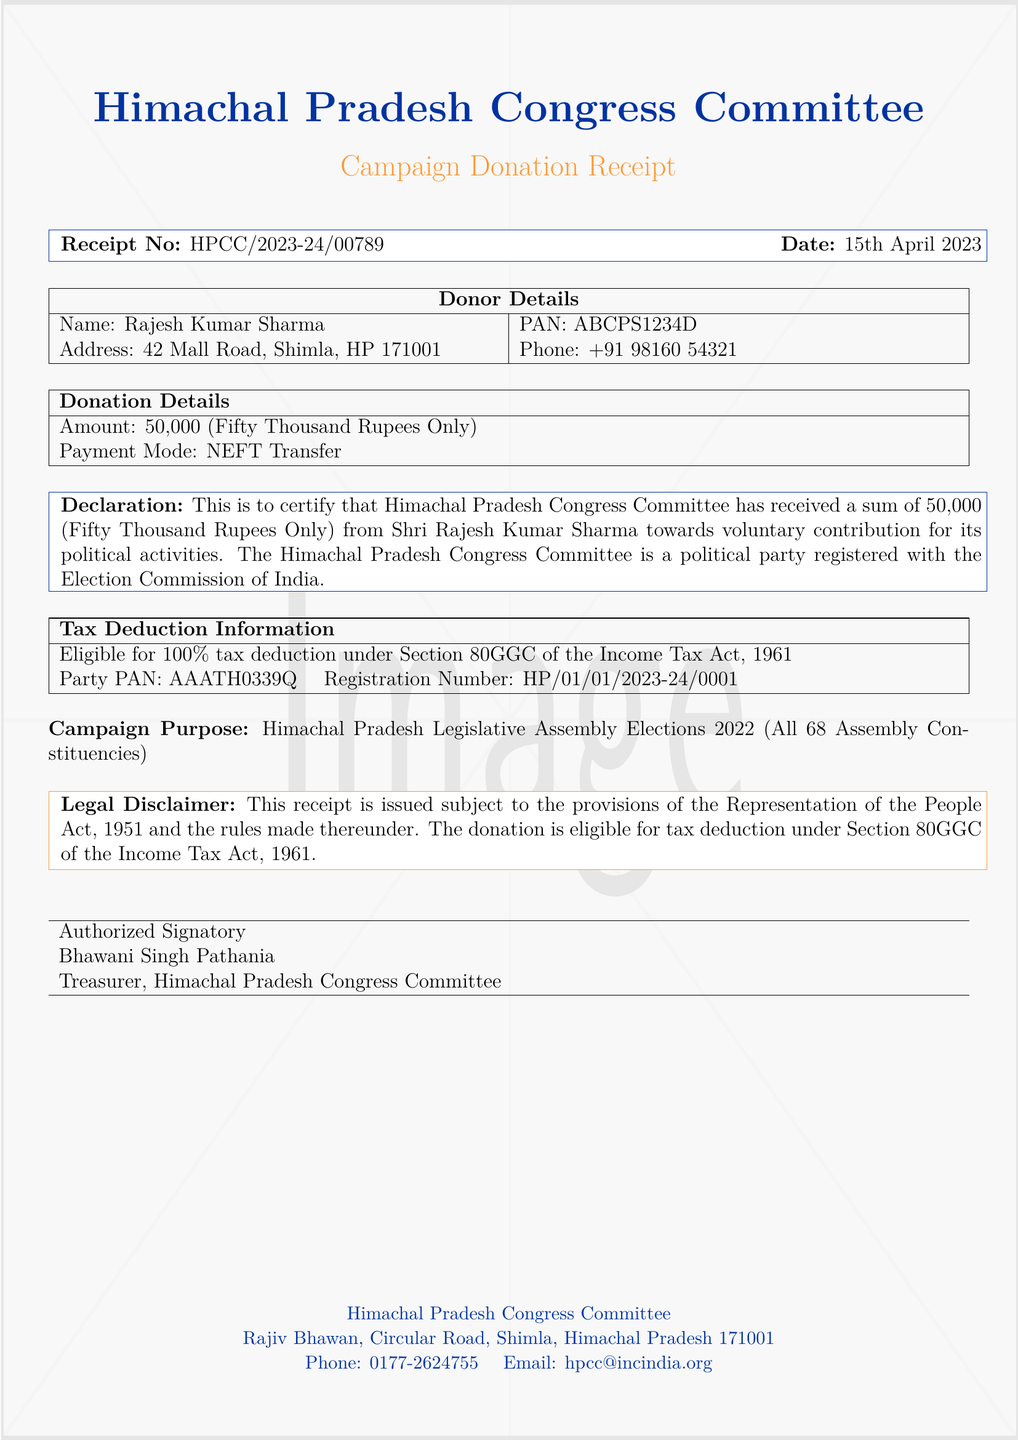What is the name of the donor? The donor's name is explicitly mentioned in the document as Rajesh Kumar Sharma.
Answer: Rajesh Kumar Sharma What is the amount donated? The donation amount is clearly stated in the donation details section of the document as ₹50,000.
Answer: ₹50,000 When was the donation made? The date of the donation is specified in the donation details section as 15th April 2023.
Answer: 15th April 2023 Who issued the receipt? The issuer of the receipt is mentioned as Bhawani Singh Pathania in the receipt details section.
Answer: Bhawani Singh Pathania What section of the Income Tax Act provides tax deduction for this donation? The section providing tax deduction is specified as 80GGC of the Income Tax Act, 1961.
Answer: 80GGC How is the donation payment made? The payment mode for the donation is clearly stated as NEFT Transfer.
Answer: NEFT Transfer What is the registration number of the Himachal Pradesh Congress Committee? The registration number of the party is provided as HP/01/01/2023-24/0001.
Answer: HP/01/01/2023-24/0001 What is the purpose of the campaign for which the donation was made? The campaign purpose relates to the Himachal Pradesh Legislative Assembly Elections 2022, covering all 68 assembly constituencies.
Answer: Himachal Pradesh Legislative Assembly Elections 2022 Which party is the donation eligible for a tax deduction? The document states the donation is eligible for tax deduction under the provisions of the Income Tax Act, specifically mentioned for the Himachal Pradesh Congress Committee.
Answer: Himachal Pradesh Congress Committee 